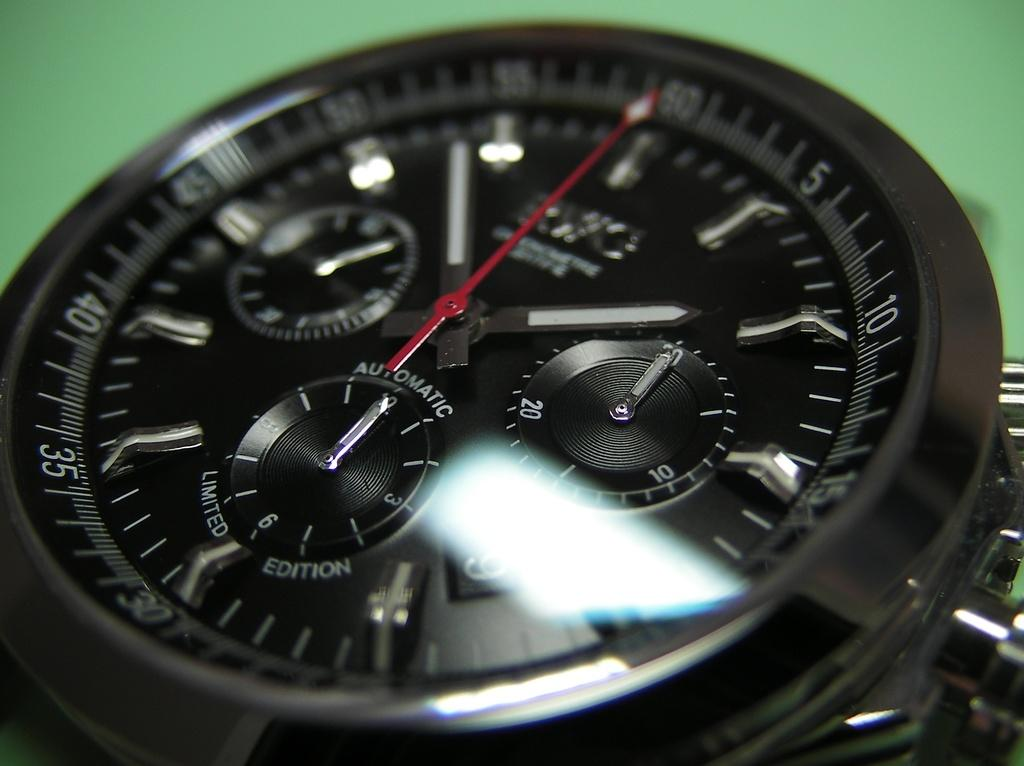<image>
Describe the image concisely. The close up of the watch face says, 'Automatic Limited Edition'. 